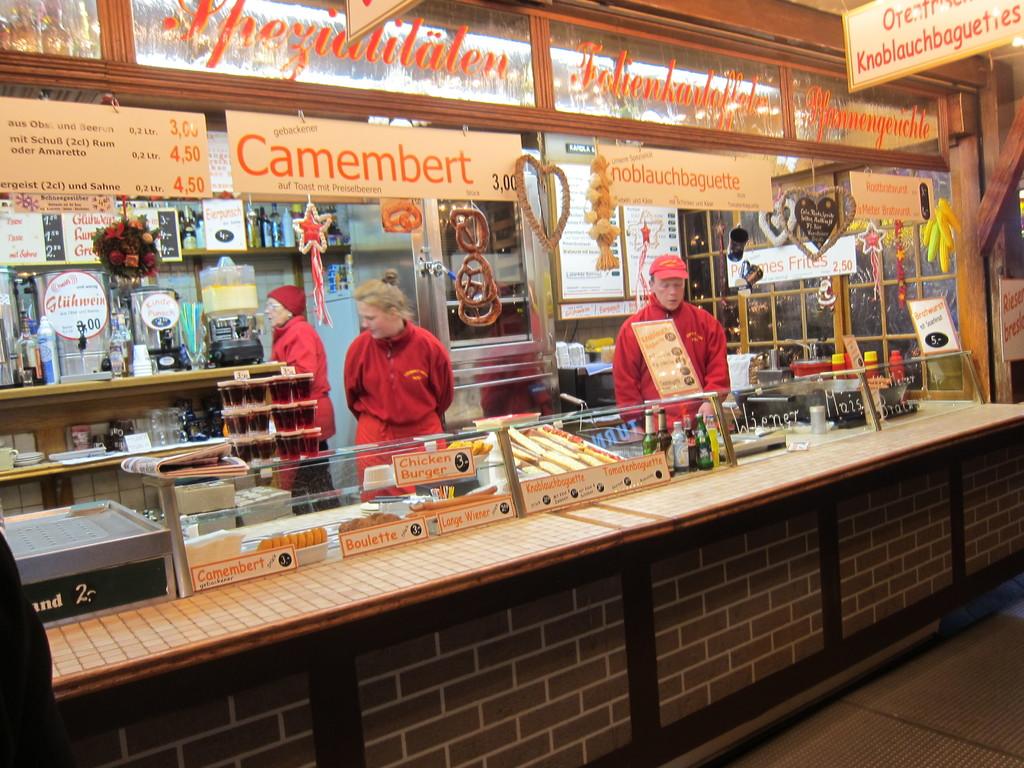What item is advertised above the blonde girl?
Your response must be concise. Camembert. 